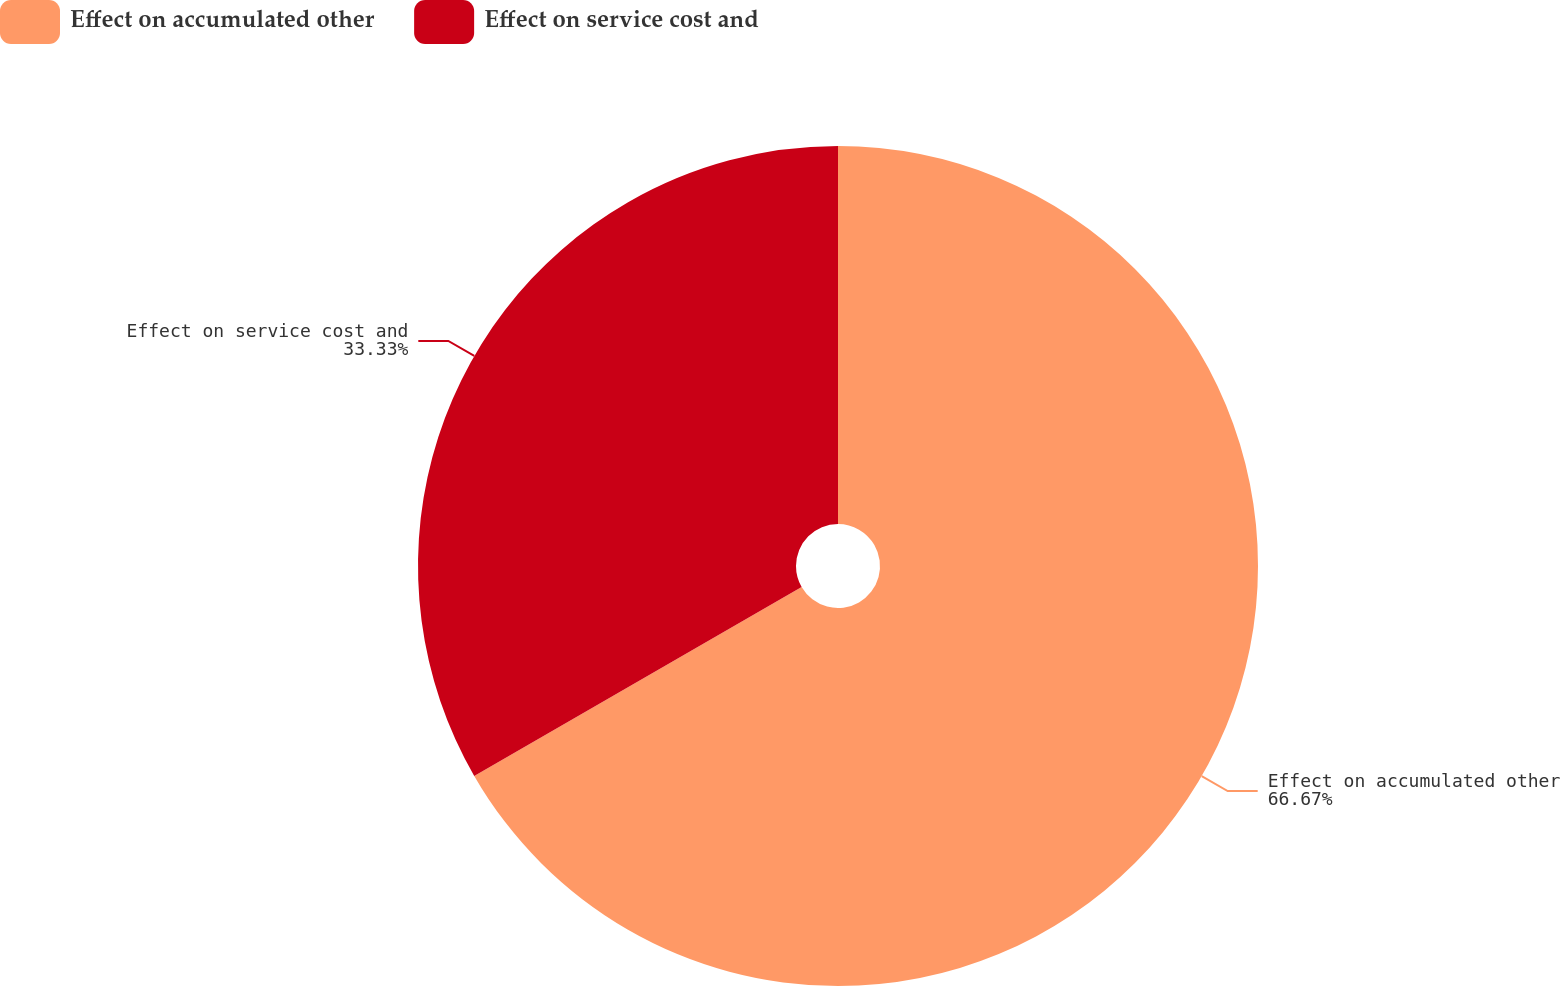Convert chart. <chart><loc_0><loc_0><loc_500><loc_500><pie_chart><fcel>Effect on accumulated other<fcel>Effect on service cost and<nl><fcel>66.67%<fcel>33.33%<nl></chart> 